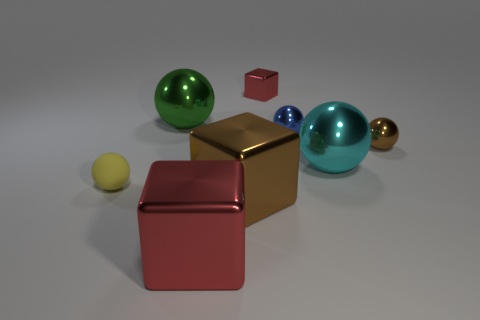Subtract all gray spheres. Subtract all gray cubes. How many spheres are left? 5 Add 2 brown objects. How many objects exist? 10 Subtract all blocks. How many objects are left? 5 Subtract all big purple blocks. Subtract all big green shiny spheres. How many objects are left? 7 Add 4 tiny metallic objects. How many tiny metallic objects are left? 7 Add 8 big red cubes. How many big red cubes exist? 9 Subtract 1 green spheres. How many objects are left? 7 